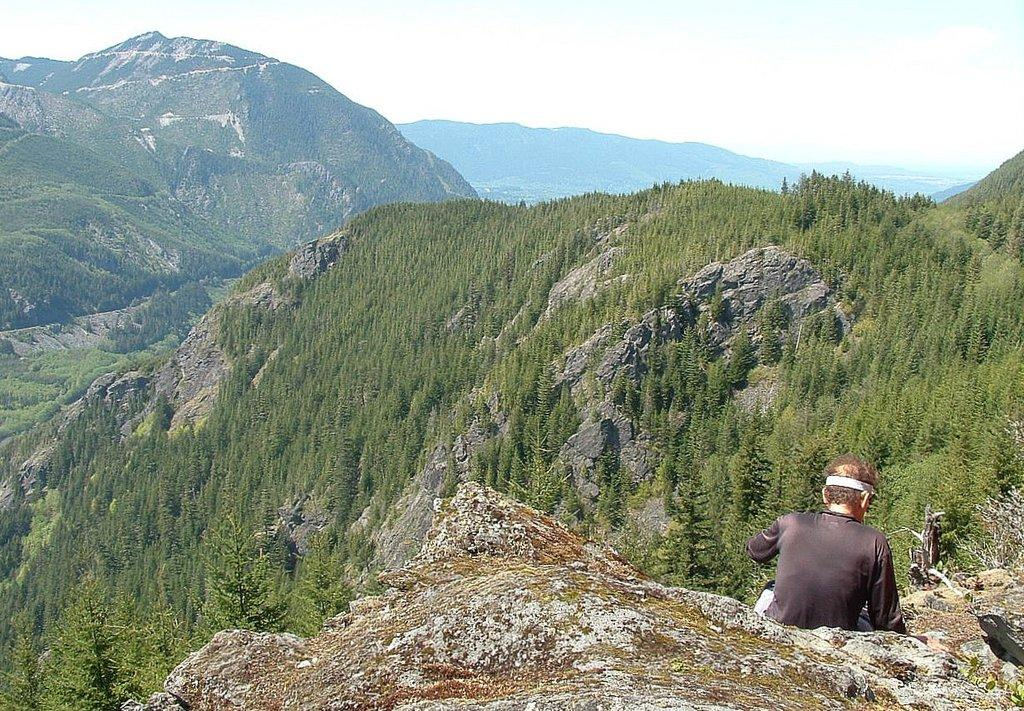Where is the man located in the image? The man is sitting on the right side of the image. What is the man sitting on? The man is sitting on a hill. What can be seen in the background of the image? There are hills and the sky visible in the background of the image. What type of grape is growing in the middle of the image? There is no grape present in the image; it features a man sitting on a hill with hills and the sky visible in the background. 